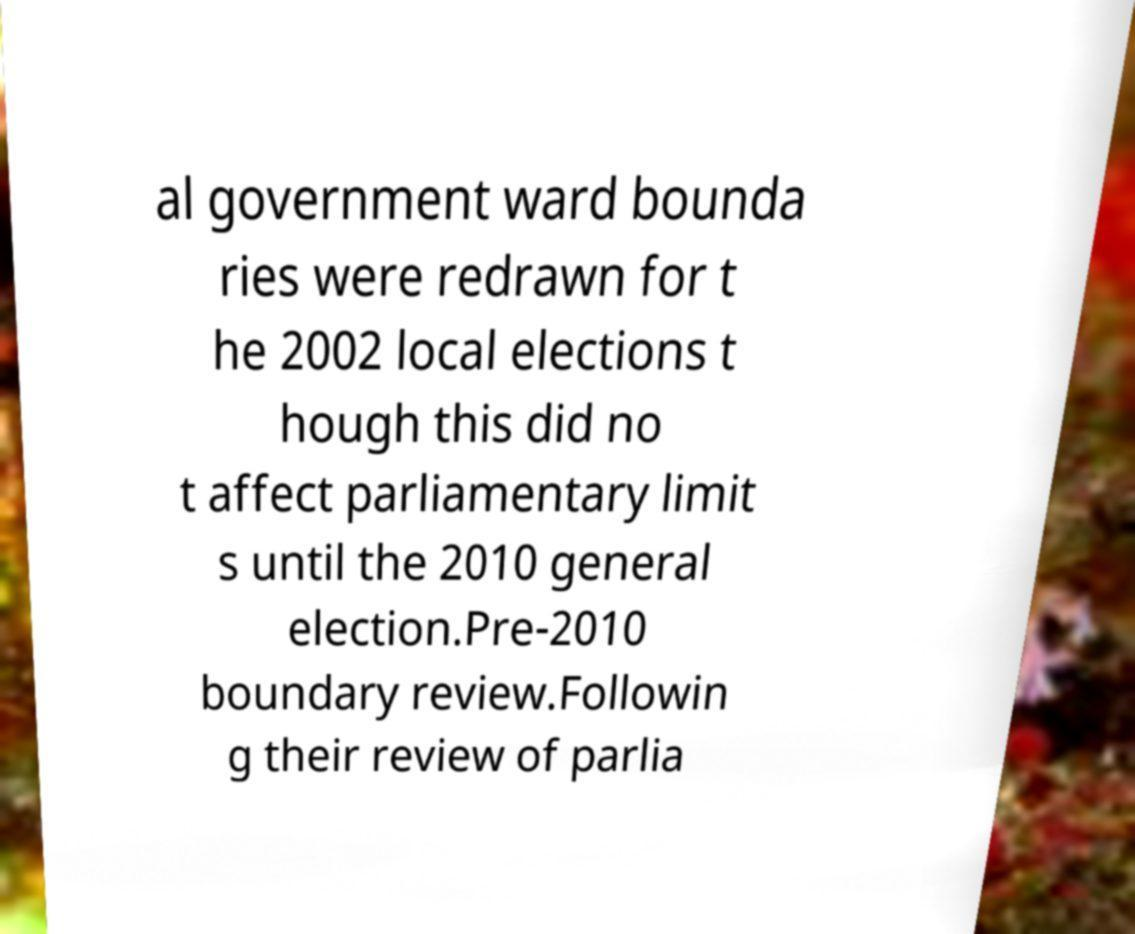Can you read and provide the text displayed in the image?This photo seems to have some interesting text. Can you extract and type it out for me? al government ward bounda ries were redrawn for t he 2002 local elections t hough this did no t affect parliamentary limit s until the 2010 general election.Pre-2010 boundary review.Followin g their review of parlia 